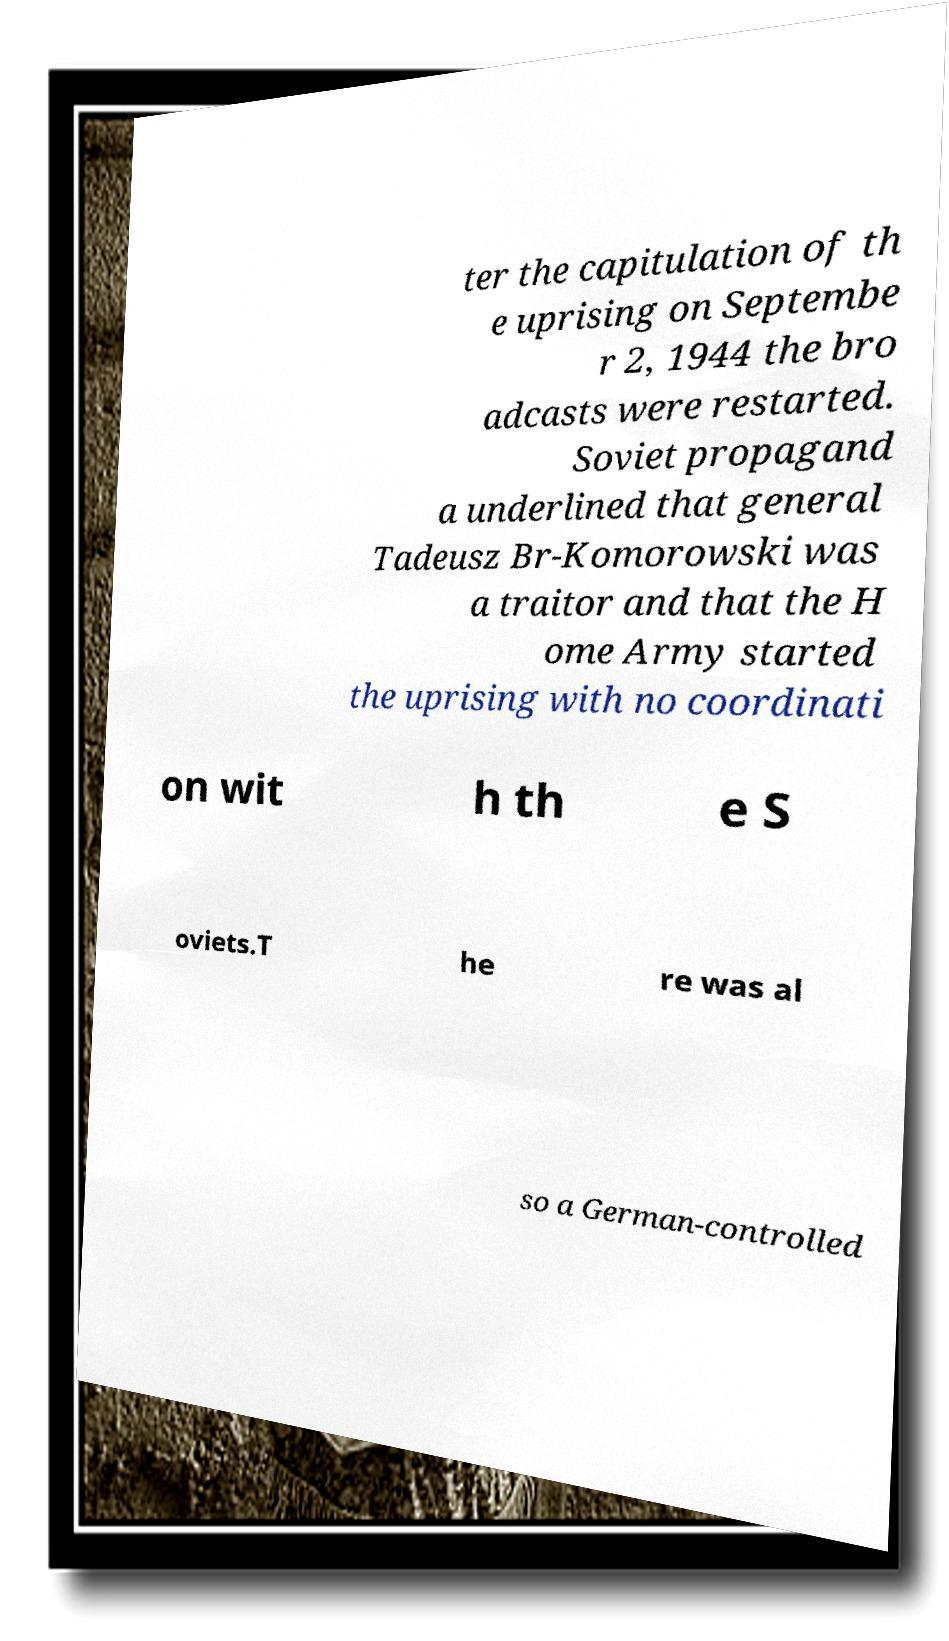Please identify and transcribe the text found in this image. ter the capitulation of th e uprising on Septembe r 2, 1944 the bro adcasts were restarted. Soviet propagand a underlined that general Tadeusz Br-Komorowski was a traitor and that the H ome Army started the uprising with no coordinati on wit h th e S oviets.T he re was al so a German-controlled 